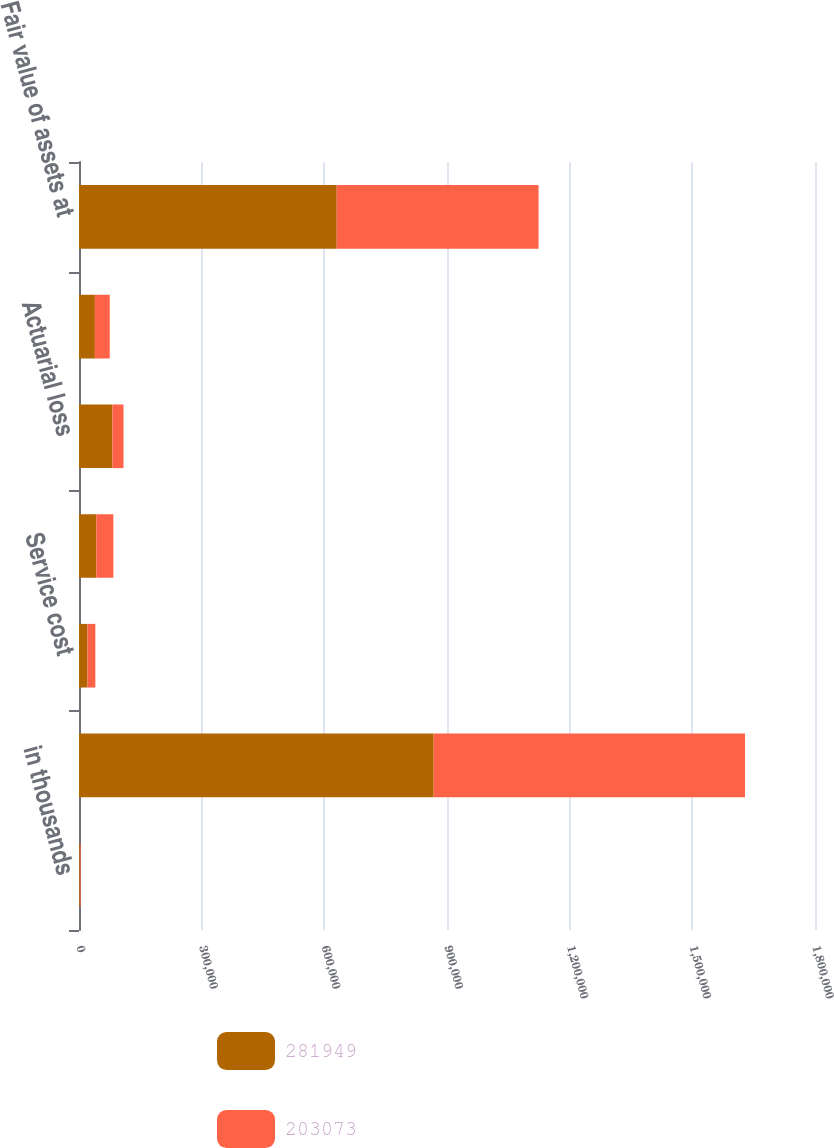Convert chart. <chart><loc_0><loc_0><loc_500><loc_500><stacked_bar_chart><ecel><fcel>in thousands<fcel>Projected benefit obligation<fcel>Service cost<fcel>Interest cost<fcel>Actuarial loss<fcel>Benefits paid<fcel>Fair value of assets at<nl><fcel>281949<fcel>2011<fcel>867374<fcel>20762<fcel>42383<fcel>81699<fcel>38854<fcel>630303<nl><fcel>203073<fcel>2010<fcel>761384<fcel>19217<fcel>41621<fcel>27094<fcel>36331<fcel>493646<nl></chart> 